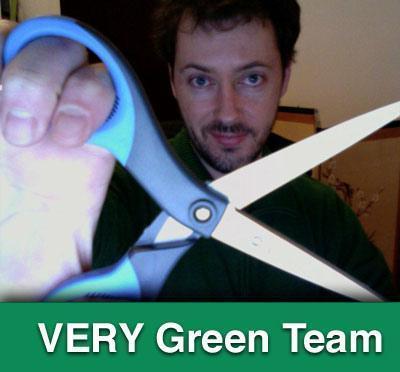How many black dogs are there?
Give a very brief answer. 0. 